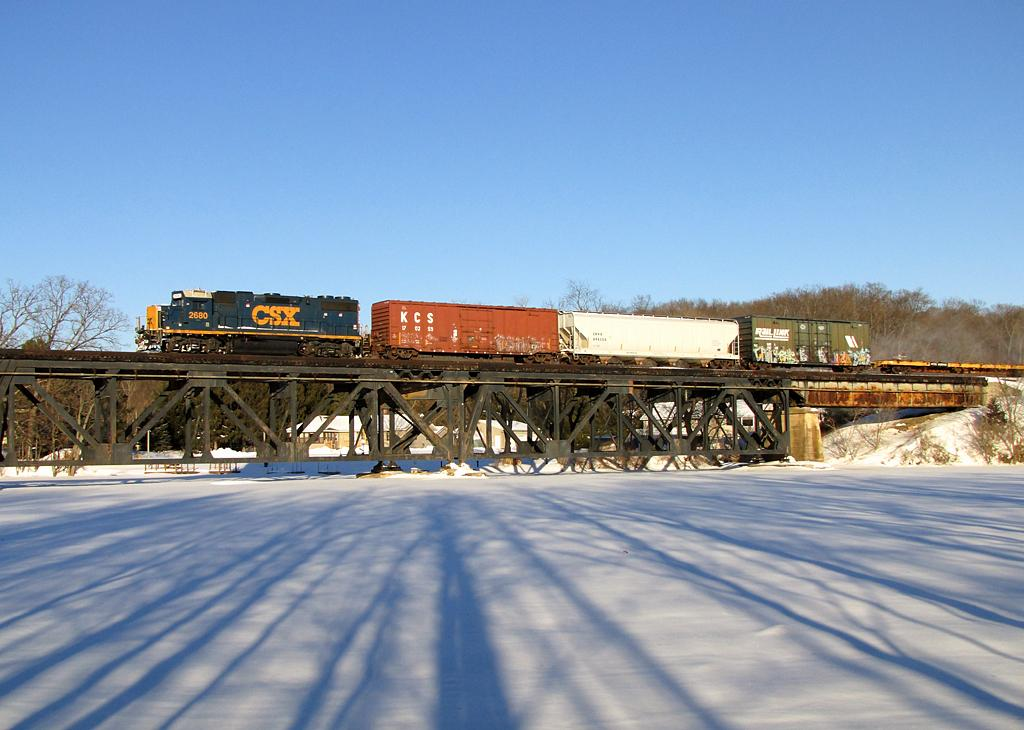<image>
Create a compact narrative representing the image presented. A CSX train leads a row of cars. 